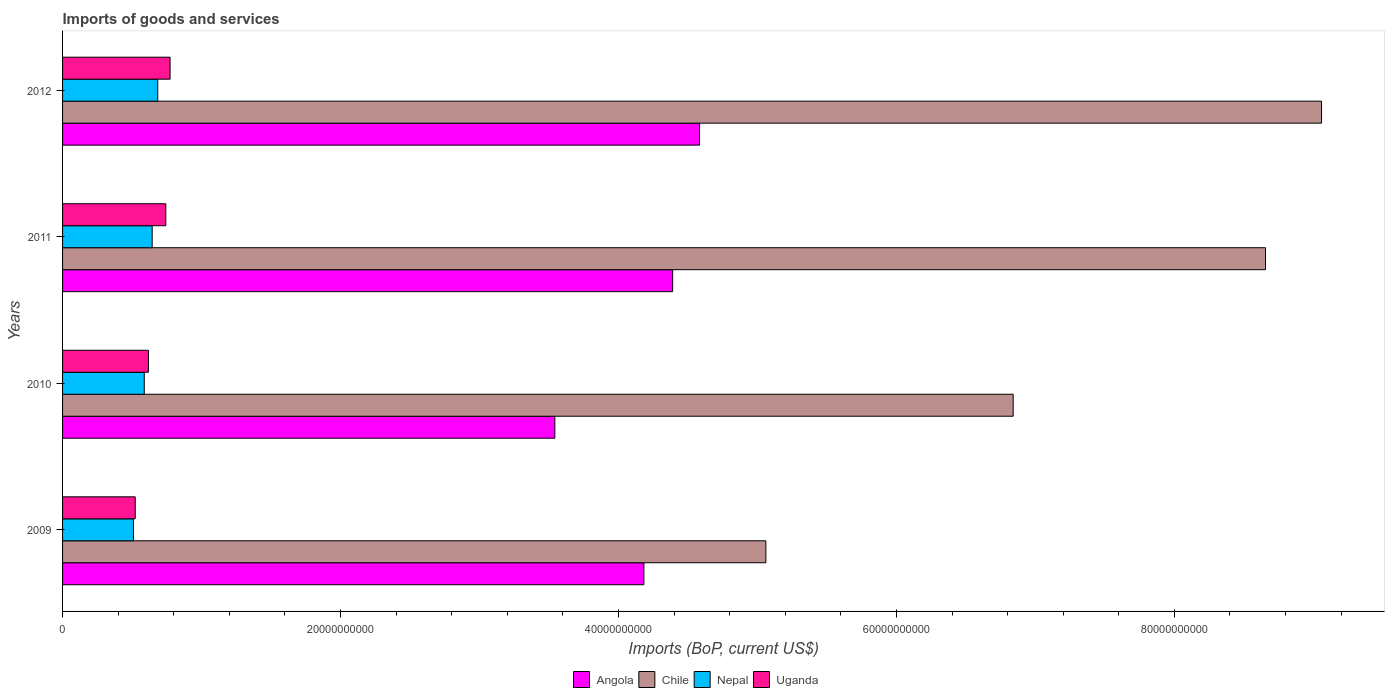How many bars are there on the 1st tick from the top?
Make the answer very short. 4. In how many cases, is the number of bars for a given year not equal to the number of legend labels?
Keep it short and to the point. 0. What is the amount spent on imports in Uganda in 2009?
Provide a short and direct response. 5.23e+09. Across all years, what is the maximum amount spent on imports in Uganda?
Your answer should be very brief. 7.74e+09. Across all years, what is the minimum amount spent on imports in Chile?
Ensure brevity in your answer.  5.06e+1. In which year was the amount spent on imports in Angola maximum?
Your response must be concise. 2012. What is the total amount spent on imports in Nepal in the graph?
Make the answer very short. 2.43e+1. What is the difference between the amount spent on imports in Nepal in 2011 and that in 2012?
Ensure brevity in your answer.  -4.00e+08. What is the difference between the amount spent on imports in Chile in 2010 and the amount spent on imports in Angola in 2012?
Offer a very short reply. 2.26e+1. What is the average amount spent on imports in Uganda per year?
Ensure brevity in your answer.  6.64e+09. In the year 2011, what is the difference between the amount spent on imports in Chile and amount spent on imports in Angola?
Offer a terse response. 4.27e+1. What is the ratio of the amount spent on imports in Angola in 2009 to that in 2012?
Your answer should be compact. 0.91. What is the difference between the highest and the second highest amount spent on imports in Angola?
Provide a succinct answer. 1.94e+09. What is the difference between the highest and the lowest amount spent on imports in Angola?
Your response must be concise. 1.04e+1. In how many years, is the amount spent on imports in Uganda greater than the average amount spent on imports in Uganda taken over all years?
Your response must be concise. 2. Is the sum of the amount spent on imports in Uganda in 2011 and 2012 greater than the maximum amount spent on imports in Chile across all years?
Offer a very short reply. No. Is it the case that in every year, the sum of the amount spent on imports in Angola and amount spent on imports in Uganda is greater than the sum of amount spent on imports in Chile and amount spent on imports in Nepal?
Ensure brevity in your answer.  No. How many years are there in the graph?
Your answer should be very brief. 4. What is the difference between two consecutive major ticks on the X-axis?
Offer a terse response. 2.00e+1. Does the graph contain grids?
Make the answer very short. No. Where does the legend appear in the graph?
Offer a terse response. Bottom center. How many legend labels are there?
Your answer should be compact. 4. How are the legend labels stacked?
Provide a short and direct response. Horizontal. What is the title of the graph?
Offer a very short reply. Imports of goods and services. What is the label or title of the X-axis?
Offer a terse response. Imports (BoP, current US$). What is the label or title of the Y-axis?
Offer a very short reply. Years. What is the Imports (BoP, current US$) of Angola in 2009?
Make the answer very short. 4.18e+1. What is the Imports (BoP, current US$) of Chile in 2009?
Your response must be concise. 5.06e+1. What is the Imports (BoP, current US$) in Nepal in 2009?
Your response must be concise. 5.10e+09. What is the Imports (BoP, current US$) in Uganda in 2009?
Offer a very short reply. 5.23e+09. What is the Imports (BoP, current US$) in Angola in 2010?
Your answer should be very brief. 3.54e+1. What is the Imports (BoP, current US$) of Chile in 2010?
Offer a terse response. 6.84e+1. What is the Imports (BoP, current US$) in Nepal in 2010?
Offer a terse response. 5.88e+09. What is the Imports (BoP, current US$) in Uganda in 2010?
Provide a short and direct response. 6.18e+09. What is the Imports (BoP, current US$) of Angola in 2011?
Make the answer very short. 4.39e+1. What is the Imports (BoP, current US$) of Chile in 2011?
Give a very brief answer. 8.66e+1. What is the Imports (BoP, current US$) in Nepal in 2011?
Your response must be concise. 6.45e+09. What is the Imports (BoP, current US$) in Uganda in 2011?
Give a very brief answer. 7.43e+09. What is the Imports (BoP, current US$) in Angola in 2012?
Offer a very short reply. 4.58e+1. What is the Imports (BoP, current US$) of Chile in 2012?
Provide a succinct answer. 9.06e+1. What is the Imports (BoP, current US$) of Nepal in 2012?
Make the answer very short. 6.85e+09. What is the Imports (BoP, current US$) of Uganda in 2012?
Give a very brief answer. 7.74e+09. Across all years, what is the maximum Imports (BoP, current US$) in Angola?
Give a very brief answer. 4.58e+1. Across all years, what is the maximum Imports (BoP, current US$) of Chile?
Provide a succinct answer. 9.06e+1. Across all years, what is the maximum Imports (BoP, current US$) of Nepal?
Keep it short and to the point. 6.85e+09. Across all years, what is the maximum Imports (BoP, current US$) of Uganda?
Your answer should be very brief. 7.74e+09. Across all years, what is the minimum Imports (BoP, current US$) of Angola?
Provide a succinct answer. 3.54e+1. Across all years, what is the minimum Imports (BoP, current US$) of Chile?
Your response must be concise. 5.06e+1. Across all years, what is the minimum Imports (BoP, current US$) in Nepal?
Your response must be concise. 5.10e+09. Across all years, what is the minimum Imports (BoP, current US$) in Uganda?
Your response must be concise. 5.23e+09. What is the total Imports (BoP, current US$) in Angola in the graph?
Ensure brevity in your answer.  1.67e+11. What is the total Imports (BoP, current US$) in Chile in the graph?
Your answer should be very brief. 2.96e+11. What is the total Imports (BoP, current US$) in Nepal in the graph?
Ensure brevity in your answer.  2.43e+1. What is the total Imports (BoP, current US$) of Uganda in the graph?
Offer a terse response. 2.66e+1. What is the difference between the Imports (BoP, current US$) of Angola in 2009 and that in 2010?
Keep it short and to the point. 6.41e+09. What is the difference between the Imports (BoP, current US$) in Chile in 2009 and that in 2010?
Your answer should be compact. -1.78e+1. What is the difference between the Imports (BoP, current US$) in Nepal in 2009 and that in 2010?
Keep it short and to the point. -7.78e+08. What is the difference between the Imports (BoP, current US$) in Uganda in 2009 and that in 2010?
Your answer should be compact. -9.50e+08. What is the difference between the Imports (BoP, current US$) in Angola in 2009 and that in 2011?
Offer a very short reply. -2.07e+09. What is the difference between the Imports (BoP, current US$) of Chile in 2009 and that in 2011?
Your answer should be very brief. -3.60e+1. What is the difference between the Imports (BoP, current US$) of Nepal in 2009 and that in 2011?
Your response must be concise. -1.35e+09. What is the difference between the Imports (BoP, current US$) in Uganda in 2009 and that in 2011?
Your response must be concise. -2.20e+09. What is the difference between the Imports (BoP, current US$) in Angola in 2009 and that in 2012?
Offer a very short reply. -4.01e+09. What is the difference between the Imports (BoP, current US$) in Chile in 2009 and that in 2012?
Keep it short and to the point. -4.00e+1. What is the difference between the Imports (BoP, current US$) in Nepal in 2009 and that in 2012?
Give a very brief answer. -1.75e+09. What is the difference between the Imports (BoP, current US$) of Uganda in 2009 and that in 2012?
Keep it short and to the point. -2.51e+09. What is the difference between the Imports (BoP, current US$) in Angola in 2010 and that in 2011?
Your response must be concise. -8.48e+09. What is the difference between the Imports (BoP, current US$) of Chile in 2010 and that in 2011?
Give a very brief answer. -1.82e+1. What is the difference between the Imports (BoP, current US$) in Nepal in 2010 and that in 2011?
Offer a terse response. -5.68e+08. What is the difference between the Imports (BoP, current US$) in Uganda in 2010 and that in 2011?
Ensure brevity in your answer.  -1.25e+09. What is the difference between the Imports (BoP, current US$) of Angola in 2010 and that in 2012?
Your response must be concise. -1.04e+1. What is the difference between the Imports (BoP, current US$) of Chile in 2010 and that in 2012?
Give a very brief answer. -2.22e+1. What is the difference between the Imports (BoP, current US$) in Nepal in 2010 and that in 2012?
Offer a very short reply. -9.69e+08. What is the difference between the Imports (BoP, current US$) in Uganda in 2010 and that in 2012?
Your answer should be compact. -1.56e+09. What is the difference between the Imports (BoP, current US$) of Angola in 2011 and that in 2012?
Make the answer very short. -1.94e+09. What is the difference between the Imports (BoP, current US$) in Chile in 2011 and that in 2012?
Give a very brief answer. -4.03e+09. What is the difference between the Imports (BoP, current US$) in Nepal in 2011 and that in 2012?
Give a very brief answer. -4.00e+08. What is the difference between the Imports (BoP, current US$) of Uganda in 2011 and that in 2012?
Provide a succinct answer. -3.05e+08. What is the difference between the Imports (BoP, current US$) in Angola in 2009 and the Imports (BoP, current US$) in Chile in 2010?
Keep it short and to the point. -2.66e+1. What is the difference between the Imports (BoP, current US$) of Angola in 2009 and the Imports (BoP, current US$) of Nepal in 2010?
Provide a succinct answer. 3.60e+1. What is the difference between the Imports (BoP, current US$) of Angola in 2009 and the Imports (BoP, current US$) of Uganda in 2010?
Make the answer very short. 3.57e+1. What is the difference between the Imports (BoP, current US$) in Chile in 2009 and the Imports (BoP, current US$) in Nepal in 2010?
Your answer should be very brief. 4.47e+1. What is the difference between the Imports (BoP, current US$) in Chile in 2009 and the Imports (BoP, current US$) in Uganda in 2010?
Keep it short and to the point. 4.44e+1. What is the difference between the Imports (BoP, current US$) of Nepal in 2009 and the Imports (BoP, current US$) of Uganda in 2010?
Ensure brevity in your answer.  -1.08e+09. What is the difference between the Imports (BoP, current US$) of Angola in 2009 and the Imports (BoP, current US$) of Chile in 2011?
Keep it short and to the point. -4.47e+1. What is the difference between the Imports (BoP, current US$) in Angola in 2009 and the Imports (BoP, current US$) in Nepal in 2011?
Offer a terse response. 3.54e+1. What is the difference between the Imports (BoP, current US$) of Angola in 2009 and the Imports (BoP, current US$) of Uganda in 2011?
Your answer should be very brief. 3.44e+1. What is the difference between the Imports (BoP, current US$) of Chile in 2009 and the Imports (BoP, current US$) of Nepal in 2011?
Give a very brief answer. 4.42e+1. What is the difference between the Imports (BoP, current US$) of Chile in 2009 and the Imports (BoP, current US$) of Uganda in 2011?
Offer a very short reply. 4.32e+1. What is the difference between the Imports (BoP, current US$) in Nepal in 2009 and the Imports (BoP, current US$) in Uganda in 2011?
Give a very brief answer. -2.33e+09. What is the difference between the Imports (BoP, current US$) in Angola in 2009 and the Imports (BoP, current US$) in Chile in 2012?
Make the answer very short. -4.88e+1. What is the difference between the Imports (BoP, current US$) in Angola in 2009 and the Imports (BoP, current US$) in Nepal in 2012?
Ensure brevity in your answer.  3.50e+1. What is the difference between the Imports (BoP, current US$) of Angola in 2009 and the Imports (BoP, current US$) of Uganda in 2012?
Provide a short and direct response. 3.41e+1. What is the difference between the Imports (BoP, current US$) in Chile in 2009 and the Imports (BoP, current US$) in Nepal in 2012?
Provide a succinct answer. 4.38e+1. What is the difference between the Imports (BoP, current US$) of Chile in 2009 and the Imports (BoP, current US$) of Uganda in 2012?
Make the answer very short. 4.29e+1. What is the difference between the Imports (BoP, current US$) in Nepal in 2009 and the Imports (BoP, current US$) in Uganda in 2012?
Make the answer very short. -2.63e+09. What is the difference between the Imports (BoP, current US$) in Angola in 2010 and the Imports (BoP, current US$) in Chile in 2011?
Provide a succinct answer. -5.11e+1. What is the difference between the Imports (BoP, current US$) of Angola in 2010 and the Imports (BoP, current US$) of Nepal in 2011?
Offer a terse response. 2.90e+1. What is the difference between the Imports (BoP, current US$) in Angola in 2010 and the Imports (BoP, current US$) in Uganda in 2011?
Your answer should be very brief. 2.80e+1. What is the difference between the Imports (BoP, current US$) of Chile in 2010 and the Imports (BoP, current US$) of Nepal in 2011?
Ensure brevity in your answer.  6.20e+1. What is the difference between the Imports (BoP, current US$) in Chile in 2010 and the Imports (BoP, current US$) in Uganda in 2011?
Provide a succinct answer. 6.10e+1. What is the difference between the Imports (BoP, current US$) of Nepal in 2010 and the Imports (BoP, current US$) of Uganda in 2011?
Provide a succinct answer. -1.55e+09. What is the difference between the Imports (BoP, current US$) of Angola in 2010 and the Imports (BoP, current US$) of Chile in 2012?
Provide a short and direct response. -5.52e+1. What is the difference between the Imports (BoP, current US$) of Angola in 2010 and the Imports (BoP, current US$) of Nepal in 2012?
Offer a terse response. 2.86e+1. What is the difference between the Imports (BoP, current US$) in Angola in 2010 and the Imports (BoP, current US$) in Uganda in 2012?
Offer a terse response. 2.77e+1. What is the difference between the Imports (BoP, current US$) in Chile in 2010 and the Imports (BoP, current US$) in Nepal in 2012?
Provide a short and direct response. 6.16e+1. What is the difference between the Imports (BoP, current US$) of Chile in 2010 and the Imports (BoP, current US$) of Uganda in 2012?
Offer a terse response. 6.07e+1. What is the difference between the Imports (BoP, current US$) in Nepal in 2010 and the Imports (BoP, current US$) in Uganda in 2012?
Offer a very short reply. -1.86e+09. What is the difference between the Imports (BoP, current US$) of Angola in 2011 and the Imports (BoP, current US$) of Chile in 2012?
Your answer should be very brief. -4.67e+1. What is the difference between the Imports (BoP, current US$) in Angola in 2011 and the Imports (BoP, current US$) in Nepal in 2012?
Make the answer very short. 3.71e+1. What is the difference between the Imports (BoP, current US$) of Angola in 2011 and the Imports (BoP, current US$) of Uganda in 2012?
Provide a succinct answer. 3.62e+1. What is the difference between the Imports (BoP, current US$) in Chile in 2011 and the Imports (BoP, current US$) in Nepal in 2012?
Provide a short and direct response. 7.97e+1. What is the difference between the Imports (BoP, current US$) in Chile in 2011 and the Imports (BoP, current US$) in Uganda in 2012?
Provide a short and direct response. 7.88e+1. What is the difference between the Imports (BoP, current US$) in Nepal in 2011 and the Imports (BoP, current US$) in Uganda in 2012?
Give a very brief answer. -1.29e+09. What is the average Imports (BoP, current US$) in Angola per year?
Your answer should be very brief. 4.17e+1. What is the average Imports (BoP, current US$) in Chile per year?
Offer a very short reply. 7.40e+1. What is the average Imports (BoP, current US$) of Nepal per year?
Your answer should be very brief. 6.07e+09. What is the average Imports (BoP, current US$) of Uganda per year?
Keep it short and to the point. 6.64e+09. In the year 2009, what is the difference between the Imports (BoP, current US$) of Angola and Imports (BoP, current US$) of Chile?
Your answer should be compact. -8.78e+09. In the year 2009, what is the difference between the Imports (BoP, current US$) of Angola and Imports (BoP, current US$) of Nepal?
Your response must be concise. 3.67e+1. In the year 2009, what is the difference between the Imports (BoP, current US$) of Angola and Imports (BoP, current US$) of Uganda?
Your response must be concise. 3.66e+1. In the year 2009, what is the difference between the Imports (BoP, current US$) of Chile and Imports (BoP, current US$) of Nepal?
Give a very brief answer. 4.55e+1. In the year 2009, what is the difference between the Imports (BoP, current US$) in Chile and Imports (BoP, current US$) in Uganda?
Make the answer very short. 4.54e+1. In the year 2009, what is the difference between the Imports (BoP, current US$) of Nepal and Imports (BoP, current US$) of Uganda?
Make the answer very short. -1.27e+08. In the year 2010, what is the difference between the Imports (BoP, current US$) of Angola and Imports (BoP, current US$) of Chile?
Provide a succinct answer. -3.30e+1. In the year 2010, what is the difference between the Imports (BoP, current US$) of Angola and Imports (BoP, current US$) of Nepal?
Ensure brevity in your answer.  2.95e+1. In the year 2010, what is the difference between the Imports (BoP, current US$) in Angola and Imports (BoP, current US$) in Uganda?
Your answer should be very brief. 2.92e+1. In the year 2010, what is the difference between the Imports (BoP, current US$) in Chile and Imports (BoP, current US$) in Nepal?
Offer a very short reply. 6.25e+1. In the year 2010, what is the difference between the Imports (BoP, current US$) in Chile and Imports (BoP, current US$) in Uganda?
Your answer should be very brief. 6.22e+1. In the year 2010, what is the difference between the Imports (BoP, current US$) of Nepal and Imports (BoP, current US$) of Uganda?
Offer a terse response. -2.99e+08. In the year 2011, what is the difference between the Imports (BoP, current US$) of Angola and Imports (BoP, current US$) of Chile?
Keep it short and to the point. -4.27e+1. In the year 2011, what is the difference between the Imports (BoP, current US$) in Angola and Imports (BoP, current US$) in Nepal?
Your answer should be compact. 3.75e+1. In the year 2011, what is the difference between the Imports (BoP, current US$) in Angola and Imports (BoP, current US$) in Uganda?
Keep it short and to the point. 3.65e+1. In the year 2011, what is the difference between the Imports (BoP, current US$) in Chile and Imports (BoP, current US$) in Nepal?
Your answer should be very brief. 8.01e+1. In the year 2011, what is the difference between the Imports (BoP, current US$) in Chile and Imports (BoP, current US$) in Uganda?
Your response must be concise. 7.91e+1. In the year 2011, what is the difference between the Imports (BoP, current US$) of Nepal and Imports (BoP, current US$) of Uganda?
Ensure brevity in your answer.  -9.83e+08. In the year 2012, what is the difference between the Imports (BoP, current US$) of Angola and Imports (BoP, current US$) of Chile?
Keep it short and to the point. -4.48e+1. In the year 2012, what is the difference between the Imports (BoP, current US$) in Angola and Imports (BoP, current US$) in Nepal?
Make the answer very short. 3.90e+1. In the year 2012, what is the difference between the Imports (BoP, current US$) in Angola and Imports (BoP, current US$) in Uganda?
Your response must be concise. 3.81e+1. In the year 2012, what is the difference between the Imports (BoP, current US$) of Chile and Imports (BoP, current US$) of Nepal?
Give a very brief answer. 8.37e+1. In the year 2012, what is the difference between the Imports (BoP, current US$) in Chile and Imports (BoP, current US$) in Uganda?
Your answer should be compact. 8.29e+1. In the year 2012, what is the difference between the Imports (BoP, current US$) in Nepal and Imports (BoP, current US$) in Uganda?
Offer a very short reply. -8.88e+08. What is the ratio of the Imports (BoP, current US$) of Angola in 2009 to that in 2010?
Keep it short and to the point. 1.18. What is the ratio of the Imports (BoP, current US$) in Chile in 2009 to that in 2010?
Ensure brevity in your answer.  0.74. What is the ratio of the Imports (BoP, current US$) in Nepal in 2009 to that in 2010?
Offer a terse response. 0.87. What is the ratio of the Imports (BoP, current US$) of Uganda in 2009 to that in 2010?
Your response must be concise. 0.85. What is the ratio of the Imports (BoP, current US$) in Angola in 2009 to that in 2011?
Make the answer very short. 0.95. What is the ratio of the Imports (BoP, current US$) in Chile in 2009 to that in 2011?
Your answer should be very brief. 0.58. What is the ratio of the Imports (BoP, current US$) of Nepal in 2009 to that in 2011?
Your response must be concise. 0.79. What is the ratio of the Imports (BoP, current US$) in Uganda in 2009 to that in 2011?
Keep it short and to the point. 0.7. What is the ratio of the Imports (BoP, current US$) of Angola in 2009 to that in 2012?
Provide a succinct answer. 0.91. What is the ratio of the Imports (BoP, current US$) in Chile in 2009 to that in 2012?
Your answer should be very brief. 0.56. What is the ratio of the Imports (BoP, current US$) of Nepal in 2009 to that in 2012?
Your response must be concise. 0.74. What is the ratio of the Imports (BoP, current US$) in Uganda in 2009 to that in 2012?
Give a very brief answer. 0.68. What is the ratio of the Imports (BoP, current US$) in Angola in 2010 to that in 2011?
Offer a very short reply. 0.81. What is the ratio of the Imports (BoP, current US$) in Chile in 2010 to that in 2011?
Your answer should be very brief. 0.79. What is the ratio of the Imports (BoP, current US$) in Nepal in 2010 to that in 2011?
Give a very brief answer. 0.91. What is the ratio of the Imports (BoP, current US$) of Uganda in 2010 to that in 2011?
Give a very brief answer. 0.83. What is the ratio of the Imports (BoP, current US$) in Angola in 2010 to that in 2012?
Your answer should be very brief. 0.77. What is the ratio of the Imports (BoP, current US$) in Chile in 2010 to that in 2012?
Your answer should be very brief. 0.76. What is the ratio of the Imports (BoP, current US$) in Nepal in 2010 to that in 2012?
Offer a very short reply. 0.86. What is the ratio of the Imports (BoP, current US$) in Uganda in 2010 to that in 2012?
Your response must be concise. 0.8. What is the ratio of the Imports (BoP, current US$) of Angola in 2011 to that in 2012?
Offer a very short reply. 0.96. What is the ratio of the Imports (BoP, current US$) in Chile in 2011 to that in 2012?
Provide a short and direct response. 0.96. What is the ratio of the Imports (BoP, current US$) in Nepal in 2011 to that in 2012?
Keep it short and to the point. 0.94. What is the ratio of the Imports (BoP, current US$) of Uganda in 2011 to that in 2012?
Ensure brevity in your answer.  0.96. What is the difference between the highest and the second highest Imports (BoP, current US$) of Angola?
Ensure brevity in your answer.  1.94e+09. What is the difference between the highest and the second highest Imports (BoP, current US$) in Chile?
Your answer should be compact. 4.03e+09. What is the difference between the highest and the second highest Imports (BoP, current US$) of Nepal?
Keep it short and to the point. 4.00e+08. What is the difference between the highest and the second highest Imports (BoP, current US$) in Uganda?
Give a very brief answer. 3.05e+08. What is the difference between the highest and the lowest Imports (BoP, current US$) in Angola?
Ensure brevity in your answer.  1.04e+1. What is the difference between the highest and the lowest Imports (BoP, current US$) in Chile?
Offer a very short reply. 4.00e+1. What is the difference between the highest and the lowest Imports (BoP, current US$) of Nepal?
Offer a terse response. 1.75e+09. What is the difference between the highest and the lowest Imports (BoP, current US$) of Uganda?
Make the answer very short. 2.51e+09. 